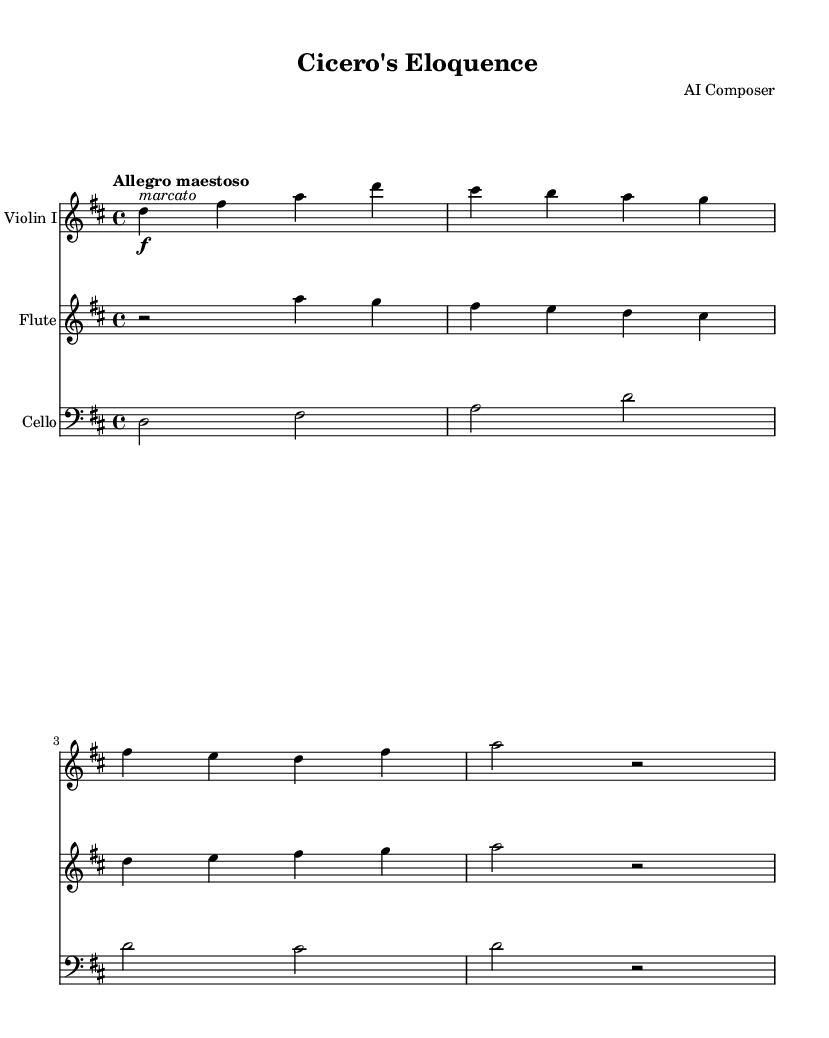What is the key signature of this music? The key signature indicated in the sheet music is D major, which contains two sharps (F# and C#). This can be identified by looking at the key signature found at the beginning of the staff.
Answer: D major What is the time signature of this music? The time signature is located at the beginning of the music and is displayed as 4/4, indicating four beats per measure with each beat represented by a quarter note.
Answer: 4/4 What is the tempo marking for this piece? The tempo marking appears at the beginning of the score, indicating "Allegro maestoso," which describes the desired speed and character of the music as fast and majestic.
Answer: Allegro maestoso How many measures are in the violin part? By counting the measures in the violin part, we see there are four measures presented. Each distinct group of notes between the vertical lines represents a measure.
Answer: Four What dynamic marking is included in the violin part? The violin part includes a dynamic marking of "f" which indicates that this section should be played forte (loud). This is represented by the "f" placed before the note where the dynamic change occurs.
Answer: Forte Which instrument plays the lowest pitch in the score? The cello plays the lowest pitch in the score. By observing the staff for cello, we can see that it starts from a lower pitch range compared to the violin and flute.
Answer: Cello What rhetorical technique is reflected in the musical phrases of this symphony? The musical phrases exhibit a call-and-response structure, a technique often used in oratory to engage the audience, as it creates a dialogue-like effect. This can be noted in the alternating phrases between the violin and flute.
Answer: Call-and-response 